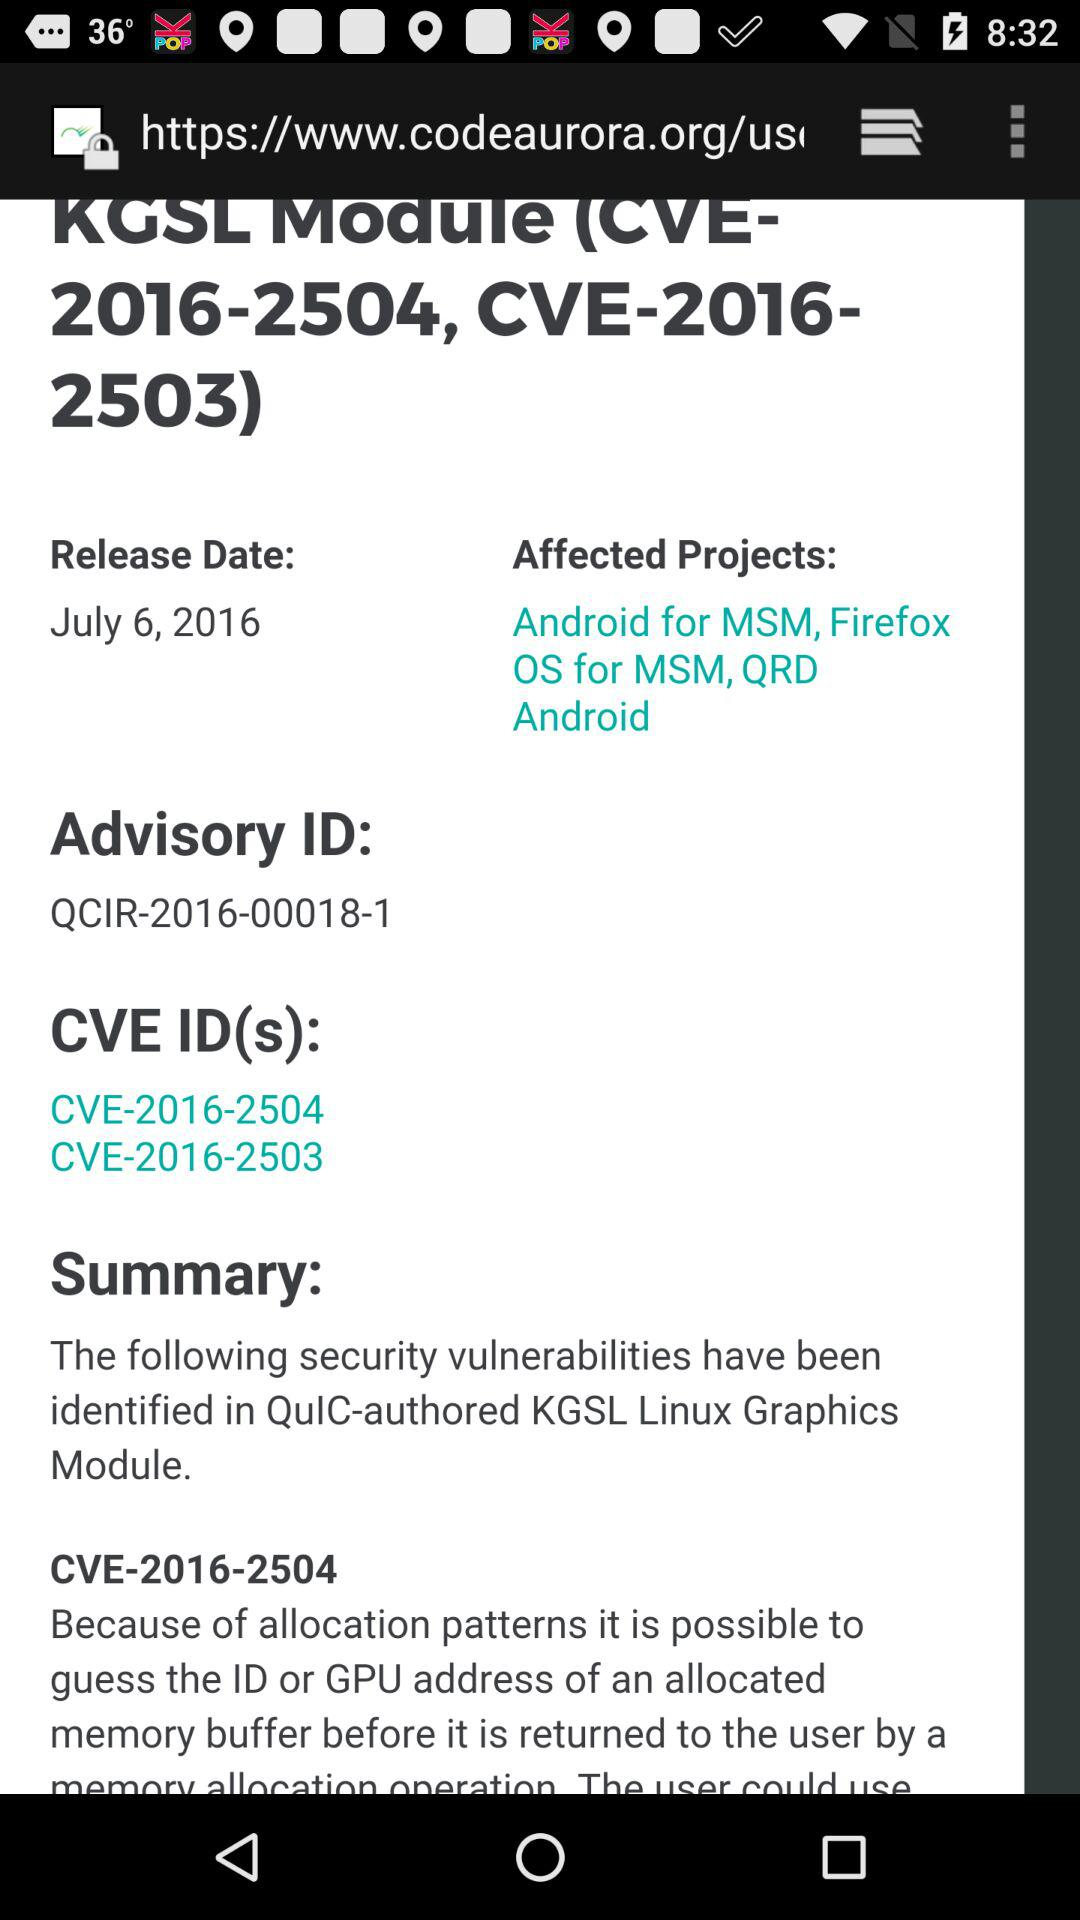What is the advisory ID? The advisory ID is QCIR-2016-00018-1. 